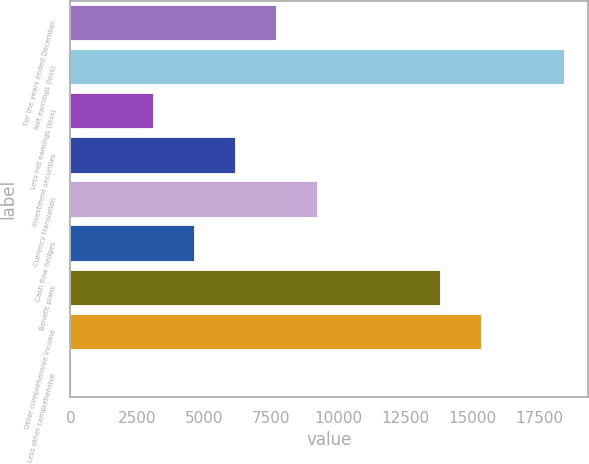Convert chart to OTSL. <chart><loc_0><loc_0><loc_500><loc_500><bar_chart><fcel>For the years ended December<fcel>Net earnings (loss)<fcel>Less net earnings (loss)<fcel>Investment securities<fcel>Currency translation<fcel>Cash flow hedges<fcel>Benefit plans<fcel>Other comprehensive income<fcel>Less other comprehensive<nl><fcel>7679<fcel>18411.4<fcel>3079.4<fcel>6145.8<fcel>9212.2<fcel>4612.6<fcel>13811.8<fcel>15345<fcel>13<nl></chart> 